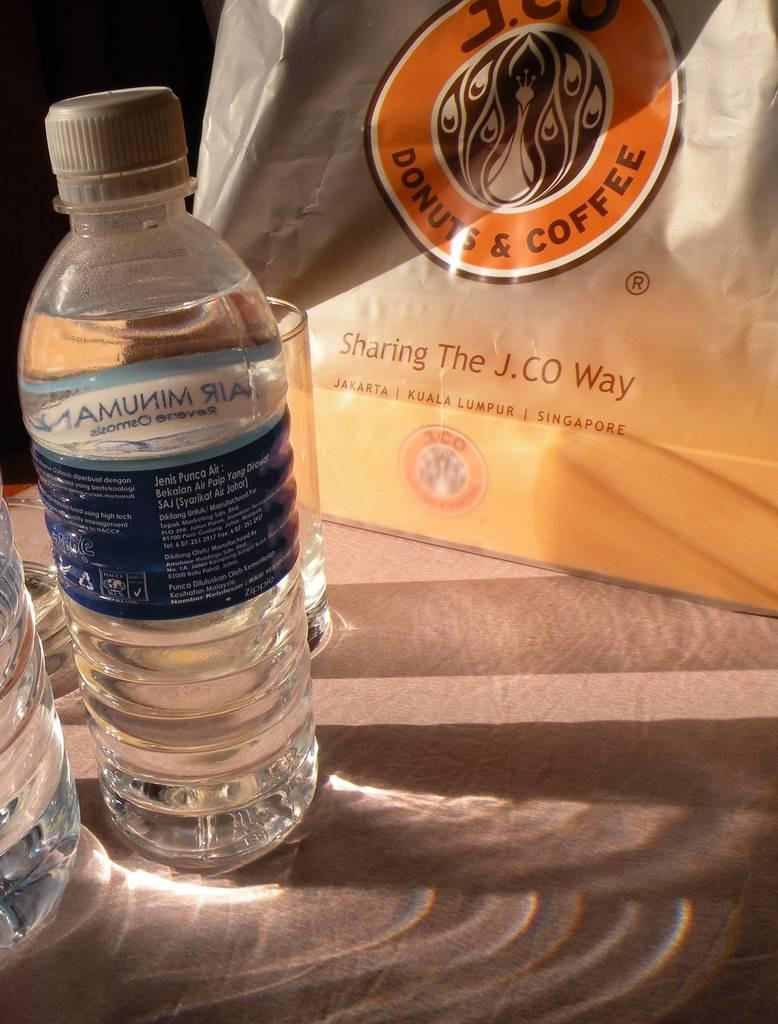<image>
Summarize the visual content of the image. Two water bottles and a glass are next to a Donuts & Coffee bag. 